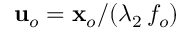Convert formula to latex. <formula><loc_0><loc_0><loc_500><loc_500>u _ { o } = x _ { o } / ( \lambda _ { 2 } \, f _ { o } )</formula> 